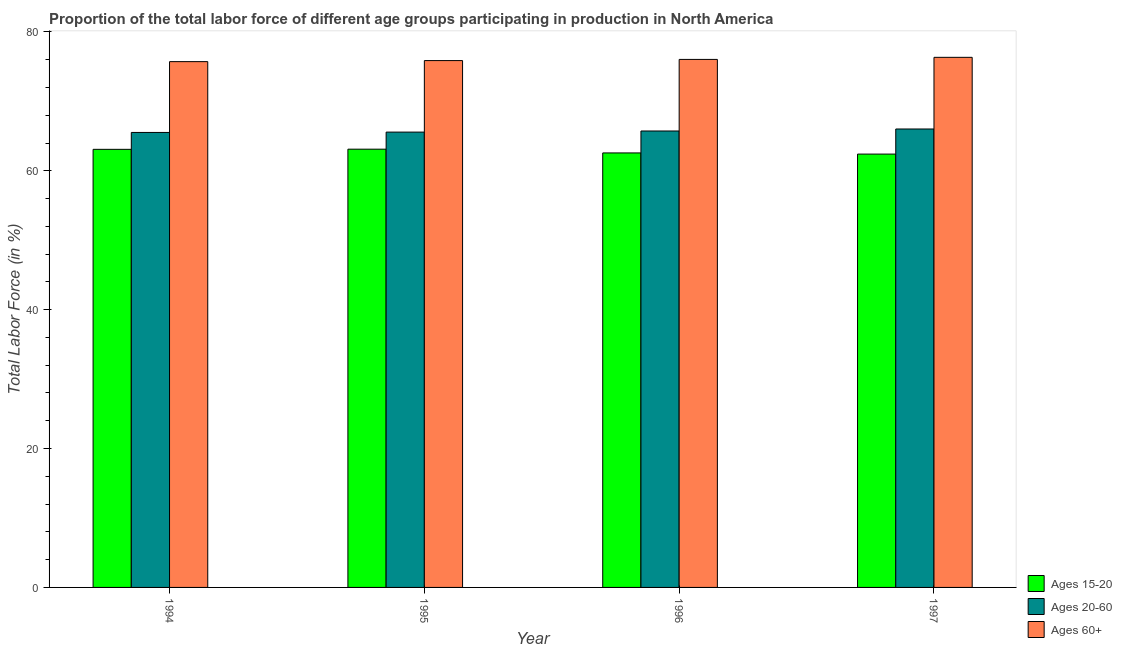How many different coloured bars are there?
Provide a short and direct response. 3. How many groups of bars are there?
Your response must be concise. 4. Are the number of bars per tick equal to the number of legend labels?
Your response must be concise. Yes. What is the percentage of labor force within the age group 20-60 in 1994?
Make the answer very short. 65.52. Across all years, what is the maximum percentage of labor force above age 60?
Give a very brief answer. 76.34. Across all years, what is the minimum percentage of labor force within the age group 15-20?
Provide a succinct answer. 62.4. In which year was the percentage of labor force within the age group 20-60 minimum?
Provide a succinct answer. 1994. What is the total percentage of labor force within the age group 20-60 in the graph?
Ensure brevity in your answer.  262.83. What is the difference between the percentage of labor force within the age group 20-60 in 1994 and that in 1997?
Provide a short and direct response. -0.5. What is the difference between the percentage of labor force above age 60 in 1995 and the percentage of labor force within the age group 15-20 in 1994?
Your answer should be very brief. 0.15. What is the average percentage of labor force within the age group 15-20 per year?
Your response must be concise. 62.79. In the year 1997, what is the difference between the percentage of labor force above age 60 and percentage of labor force within the age group 20-60?
Ensure brevity in your answer.  0. In how many years, is the percentage of labor force above age 60 greater than 36 %?
Your answer should be very brief. 4. What is the ratio of the percentage of labor force within the age group 20-60 in 1994 to that in 1996?
Your answer should be very brief. 1. Is the percentage of labor force within the age group 20-60 in 1994 less than that in 1997?
Provide a short and direct response. Yes. What is the difference between the highest and the second highest percentage of labor force within the age group 20-60?
Ensure brevity in your answer.  0.29. What is the difference between the highest and the lowest percentage of labor force above age 60?
Your response must be concise. 0.62. What does the 1st bar from the left in 1995 represents?
Offer a very short reply. Ages 15-20. What does the 2nd bar from the right in 1996 represents?
Offer a terse response. Ages 20-60. Is it the case that in every year, the sum of the percentage of labor force within the age group 15-20 and percentage of labor force within the age group 20-60 is greater than the percentage of labor force above age 60?
Your answer should be compact. Yes. How many bars are there?
Offer a terse response. 12. Are the values on the major ticks of Y-axis written in scientific E-notation?
Your answer should be very brief. No. Does the graph contain grids?
Provide a succinct answer. No. Where does the legend appear in the graph?
Your answer should be very brief. Bottom right. How are the legend labels stacked?
Your response must be concise. Vertical. What is the title of the graph?
Provide a succinct answer. Proportion of the total labor force of different age groups participating in production in North America. Does "Labor Tax" appear as one of the legend labels in the graph?
Give a very brief answer. No. What is the Total Labor Force (in %) of Ages 15-20 in 1994?
Your response must be concise. 63.09. What is the Total Labor Force (in %) in Ages 20-60 in 1994?
Provide a short and direct response. 65.52. What is the Total Labor Force (in %) in Ages 60+ in 1994?
Your answer should be very brief. 75.72. What is the Total Labor Force (in %) in Ages 15-20 in 1995?
Ensure brevity in your answer.  63.11. What is the Total Labor Force (in %) of Ages 20-60 in 1995?
Offer a very short reply. 65.57. What is the Total Labor Force (in %) in Ages 60+ in 1995?
Ensure brevity in your answer.  75.87. What is the Total Labor Force (in %) in Ages 15-20 in 1996?
Provide a short and direct response. 62.57. What is the Total Labor Force (in %) of Ages 20-60 in 1996?
Give a very brief answer. 65.73. What is the Total Labor Force (in %) in Ages 60+ in 1996?
Offer a terse response. 76.04. What is the Total Labor Force (in %) in Ages 15-20 in 1997?
Ensure brevity in your answer.  62.4. What is the Total Labor Force (in %) of Ages 20-60 in 1997?
Make the answer very short. 66.02. What is the Total Labor Force (in %) in Ages 60+ in 1997?
Your response must be concise. 76.34. Across all years, what is the maximum Total Labor Force (in %) of Ages 15-20?
Provide a short and direct response. 63.11. Across all years, what is the maximum Total Labor Force (in %) of Ages 20-60?
Offer a terse response. 66.02. Across all years, what is the maximum Total Labor Force (in %) of Ages 60+?
Offer a terse response. 76.34. Across all years, what is the minimum Total Labor Force (in %) in Ages 15-20?
Offer a very short reply. 62.4. Across all years, what is the minimum Total Labor Force (in %) of Ages 20-60?
Ensure brevity in your answer.  65.52. Across all years, what is the minimum Total Labor Force (in %) of Ages 60+?
Provide a short and direct response. 75.72. What is the total Total Labor Force (in %) of Ages 15-20 in the graph?
Ensure brevity in your answer.  251.17. What is the total Total Labor Force (in %) of Ages 20-60 in the graph?
Offer a terse response. 262.83. What is the total Total Labor Force (in %) of Ages 60+ in the graph?
Make the answer very short. 303.96. What is the difference between the Total Labor Force (in %) of Ages 15-20 in 1994 and that in 1995?
Provide a succinct answer. -0.02. What is the difference between the Total Labor Force (in %) of Ages 20-60 in 1994 and that in 1995?
Your answer should be very brief. -0.05. What is the difference between the Total Labor Force (in %) in Ages 60+ in 1994 and that in 1995?
Offer a very short reply. -0.15. What is the difference between the Total Labor Force (in %) in Ages 15-20 in 1994 and that in 1996?
Ensure brevity in your answer.  0.52. What is the difference between the Total Labor Force (in %) in Ages 20-60 in 1994 and that in 1996?
Your answer should be very brief. -0.21. What is the difference between the Total Labor Force (in %) in Ages 60+ in 1994 and that in 1996?
Your answer should be compact. -0.32. What is the difference between the Total Labor Force (in %) of Ages 15-20 in 1994 and that in 1997?
Your answer should be very brief. 0.68. What is the difference between the Total Labor Force (in %) in Ages 20-60 in 1994 and that in 1997?
Your response must be concise. -0.5. What is the difference between the Total Labor Force (in %) of Ages 60+ in 1994 and that in 1997?
Keep it short and to the point. -0.62. What is the difference between the Total Labor Force (in %) of Ages 15-20 in 1995 and that in 1996?
Your answer should be compact. 0.54. What is the difference between the Total Labor Force (in %) in Ages 20-60 in 1995 and that in 1996?
Offer a very short reply. -0.16. What is the difference between the Total Labor Force (in %) of Ages 60+ in 1995 and that in 1996?
Offer a terse response. -0.17. What is the difference between the Total Labor Force (in %) in Ages 15-20 in 1995 and that in 1997?
Offer a very short reply. 0.71. What is the difference between the Total Labor Force (in %) in Ages 20-60 in 1995 and that in 1997?
Offer a terse response. -0.45. What is the difference between the Total Labor Force (in %) in Ages 60+ in 1995 and that in 1997?
Your answer should be very brief. -0.47. What is the difference between the Total Labor Force (in %) in Ages 15-20 in 1996 and that in 1997?
Ensure brevity in your answer.  0.17. What is the difference between the Total Labor Force (in %) of Ages 20-60 in 1996 and that in 1997?
Ensure brevity in your answer.  -0.29. What is the difference between the Total Labor Force (in %) of Ages 60+ in 1996 and that in 1997?
Your response must be concise. -0.3. What is the difference between the Total Labor Force (in %) in Ages 15-20 in 1994 and the Total Labor Force (in %) in Ages 20-60 in 1995?
Your answer should be very brief. -2.48. What is the difference between the Total Labor Force (in %) in Ages 15-20 in 1994 and the Total Labor Force (in %) in Ages 60+ in 1995?
Make the answer very short. -12.78. What is the difference between the Total Labor Force (in %) in Ages 20-60 in 1994 and the Total Labor Force (in %) in Ages 60+ in 1995?
Offer a terse response. -10.35. What is the difference between the Total Labor Force (in %) of Ages 15-20 in 1994 and the Total Labor Force (in %) of Ages 20-60 in 1996?
Provide a succinct answer. -2.64. What is the difference between the Total Labor Force (in %) of Ages 15-20 in 1994 and the Total Labor Force (in %) of Ages 60+ in 1996?
Offer a very short reply. -12.95. What is the difference between the Total Labor Force (in %) of Ages 20-60 in 1994 and the Total Labor Force (in %) of Ages 60+ in 1996?
Keep it short and to the point. -10.52. What is the difference between the Total Labor Force (in %) in Ages 15-20 in 1994 and the Total Labor Force (in %) in Ages 20-60 in 1997?
Your answer should be very brief. -2.93. What is the difference between the Total Labor Force (in %) in Ages 15-20 in 1994 and the Total Labor Force (in %) in Ages 60+ in 1997?
Provide a succinct answer. -13.25. What is the difference between the Total Labor Force (in %) in Ages 20-60 in 1994 and the Total Labor Force (in %) in Ages 60+ in 1997?
Offer a terse response. -10.82. What is the difference between the Total Labor Force (in %) in Ages 15-20 in 1995 and the Total Labor Force (in %) in Ages 20-60 in 1996?
Give a very brief answer. -2.62. What is the difference between the Total Labor Force (in %) in Ages 15-20 in 1995 and the Total Labor Force (in %) in Ages 60+ in 1996?
Provide a short and direct response. -12.93. What is the difference between the Total Labor Force (in %) in Ages 20-60 in 1995 and the Total Labor Force (in %) in Ages 60+ in 1996?
Offer a very short reply. -10.47. What is the difference between the Total Labor Force (in %) in Ages 15-20 in 1995 and the Total Labor Force (in %) in Ages 20-60 in 1997?
Ensure brevity in your answer.  -2.91. What is the difference between the Total Labor Force (in %) of Ages 15-20 in 1995 and the Total Labor Force (in %) of Ages 60+ in 1997?
Offer a very short reply. -13.23. What is the difference between the Total Labor Force (in %) of Ages 20-60 in 1995 and the Total Labor Force (in %) of Ages 60+ in 1997?
Your response must be concise. -10.77. What is the difference between the Total Labor Force (in %) in Ages 15-20 in 1996 and the Total Labor Force (in %) in Ages 20-60 in 1997?
Your answer should be very brief. -3.45. What is the difference between the Total Labor Force (in %) of Ages 15-20 in 1996 and the Total Labor Force (in %) of Ages 60+ in 1997?
Keep it short and to the point. -13.77. What is the difference between the Total Labor Force (in %) in Ages 20-60 in 1996 and the Total Labor Force (in %) in Ages 60+ in 1997?
Your answer should be very brief. -10.61. What is the average Total Labor Force (in %) of Ages 15-20 per year?
Your response must be concise. 62.79. What is the average Total Labor Force (in %) of Ages 20-60 per year?
Make the answer very short. 65.71. What is the average Total Labor Force (in %) in Ages 60+ per year?
Give a very brief answer. 75.99. In the year 1994, what is the difference between the Total Labor Force (in %) in Ages 15-20 and Total Labor Force (in %) in Ages 20-60?
Offer a very short reply. -2.43. In the year 1994, what is the difference between the Total Labor Force (in %) in Ages 15-20 and Total Labor Force (in %) in Ages 60+?
Make the answer very short. -12.63. In the year 1994, what is the difference between the Total Labor Force (in %) of Ages 20-60 and Total Labor Force (in %) of Ages 60+?
Your answer should be very brief. -10.2. In the year 1995, what is the difference between the Total Labor Force (in %) in Ages 15-20 and Total Labor Force (in %) in Ages 20-60?
Offer a terse response. -2.46. In the year 1995, what is the difference between the Total Labor Force (in %) in Ages 15-20 and Total Labor Force (in %) in Ages 60+?
Give a very brief answer. -12.76. In the year 1995, what is the difference between the Total Labor Force (in %) of Ages 20-60 and Total Labor Force (in %) of Ages 60+?
Your response must be concise. -10.3. In the year 1996, what is the difference between the Total Labor Force (in %) of Ages 15-20 and Total Labor Force (in %) of Ages 20-60?
Offer a very short reply. -3.16. In the year 1996, what is the difference between the Total Labor Force (in %) of Ages 15-20 and Total Labor Force (in %) of Ages 60+?
Your response must be concise. -13.47. In the year 1996, what is the difference between the Total Labor Force (in %) in Ages 20-60 and Total Labor Force (in %) in Ages 60+?
Provide a short and direct response. -10.31. In the year 1997, what is the difference between the Total Labor Force (in %) in Ages 15-20 and Total Labor Force (in %) in Ages 20-60?
Make the answer very short. -3.62. In the year 1997, what is the difference between the Total Labor Force (in %) in Ages 15-20 and Total Labor Force (in %) in Ages 60+?
Give a very brief answer. -13.93. In the year 1997, what is the difference between the Total Labor Force (in %) in Ages 20-60 and Total Labor Force (in %) in Ages 60+?
Keep it short and to the point. -10.32. What is the ratio of the Total Labor Force (in %) of Ages 60+ in 1994 to that in 1995?
Your answer should be very brief. 1. What is the ratio of the Total Labor Force (in %) of Ages 15-20 in 1994 to that in 1996?
Offer a very short reply. 1.01. What is the ratio of the Total Labor Force (in %) in Ages 20-60 in 1994 to that in 1996?
Make the answer very short. 1. What is the ratio of the Total Labor Force (in %) in Ages 60+ in 1994 to that in 1996?
Offer a very short reply. 1. What is the ratio of the Total Labor Force (in %) of Ages 20-60 in 1994 to that in 1997?
Give a very brief answer. 0.99. What is the ratio of the Total Labor Force (in %) in Ages 60+ in 1994 to that in 1997?
Keep it short and to the point. 0.99. What is the ratio of the Total Labor Force (in %) of Ages 15-20 in 1995 to that in 1996?
Your answer should be compact. 1.01. What is the ratio of the Total Labor Force (in %) in Ages 60+ in 1995 to that in 1996?
Your response must be concise. 1. What is the ratio of the Total Labor Force (in %) in Ages 15-20 in 1995 to that in 1997?
Keep it short and to the point. 1.01. What is the ratio of the Total Labor Force (in %) of Ages 20-60 in 1995 to that in 1997?
Provide a short and direct response. 0.99. What is the ratio of the Total Labor Force (in %) of Ages 15-20 in 1996 to that in 1997?
Provide a succinct answer. 1. What is the ratio of the Total Labor Force (in %) in Ages 60+ in 1996 to that in 1997?
Your answer should be compact. 1. What is the difference between the highest and the second highest Total Labor Force (in %) in Ages 15-20?
Offer a terse response. 0.02. What is the difference between the highest and the second highest Total Labor Force (in %) in Ages 20-60?
Make the answer very short. 0.29. What is the difference between the highest and the second highest Total Labor Force (in %) in Ages 60+?
Offer a very short reply. 0.3. What is the difference between the highest and the lowest Total Labor Force (in %) of Ages 15-20?
Your answer should be compact. 0.71. What is the difference between the highest and the lowest Total Labor Force (in %) of Ages 20-60?
Make the answer very short. 0.5. What is the difference between the highest and the lowest Total Labor Force (in %) in Ages 60+?
Ensure brevity in your answer.  0.62. 